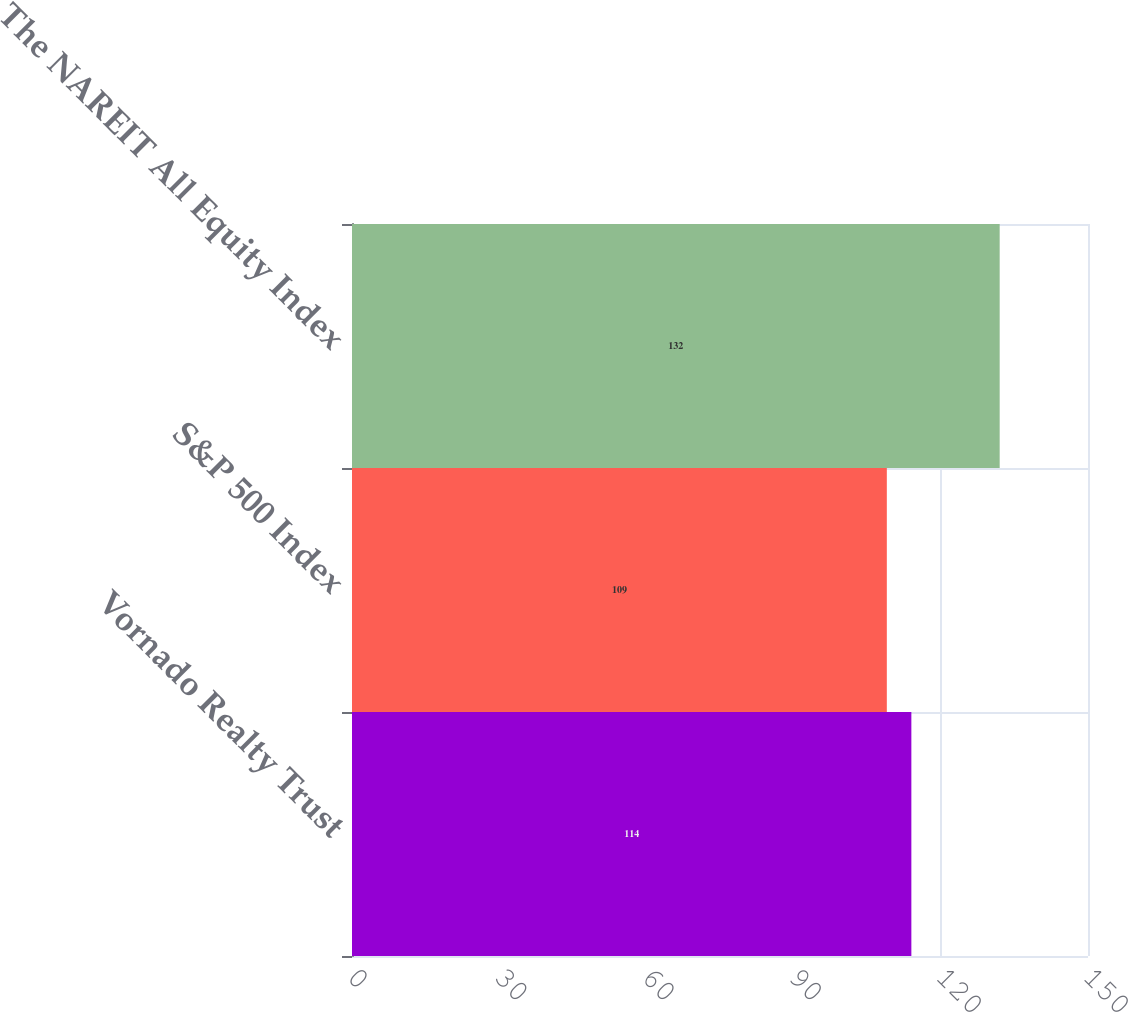Convert chart to OTSL. <chart><loc_0><loc_0><loc_500><loc_500><bar_chart><fcel>Vornado Realty Trust<fcel>S&P 500 Index<fcel>The NAREIT All Equity Index<nl><fcel>114<fcel>109<fcel>132<nl></chart> 